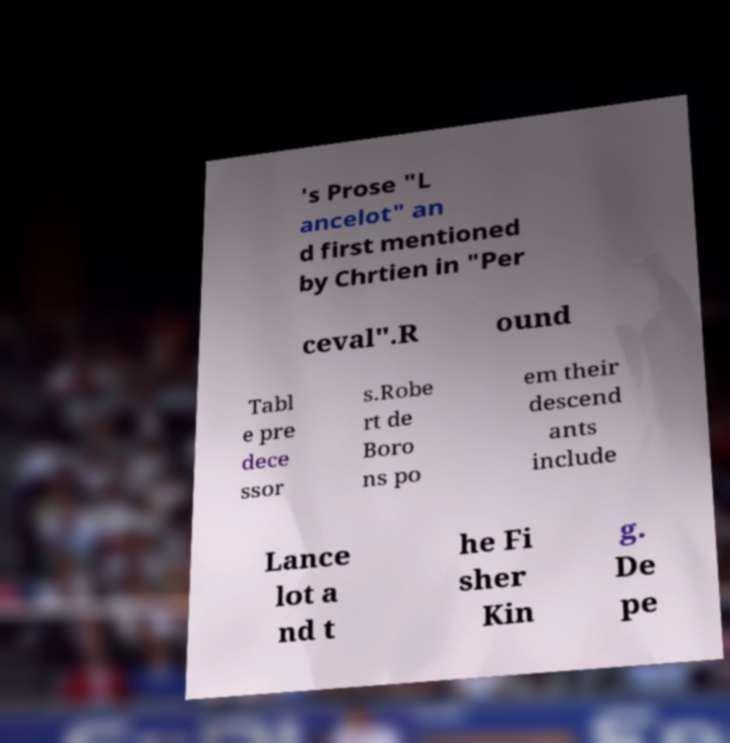Could you extract and type out the text from this image? 's Prose "L ancelot" an d first mentioned by Chrtien in "Per ceval".R ound Tabl e pre dece ssor s.Robe rt de Boro ns po em their descend ants include Lance lot a nd t he Fi sher Kin g. De pe 